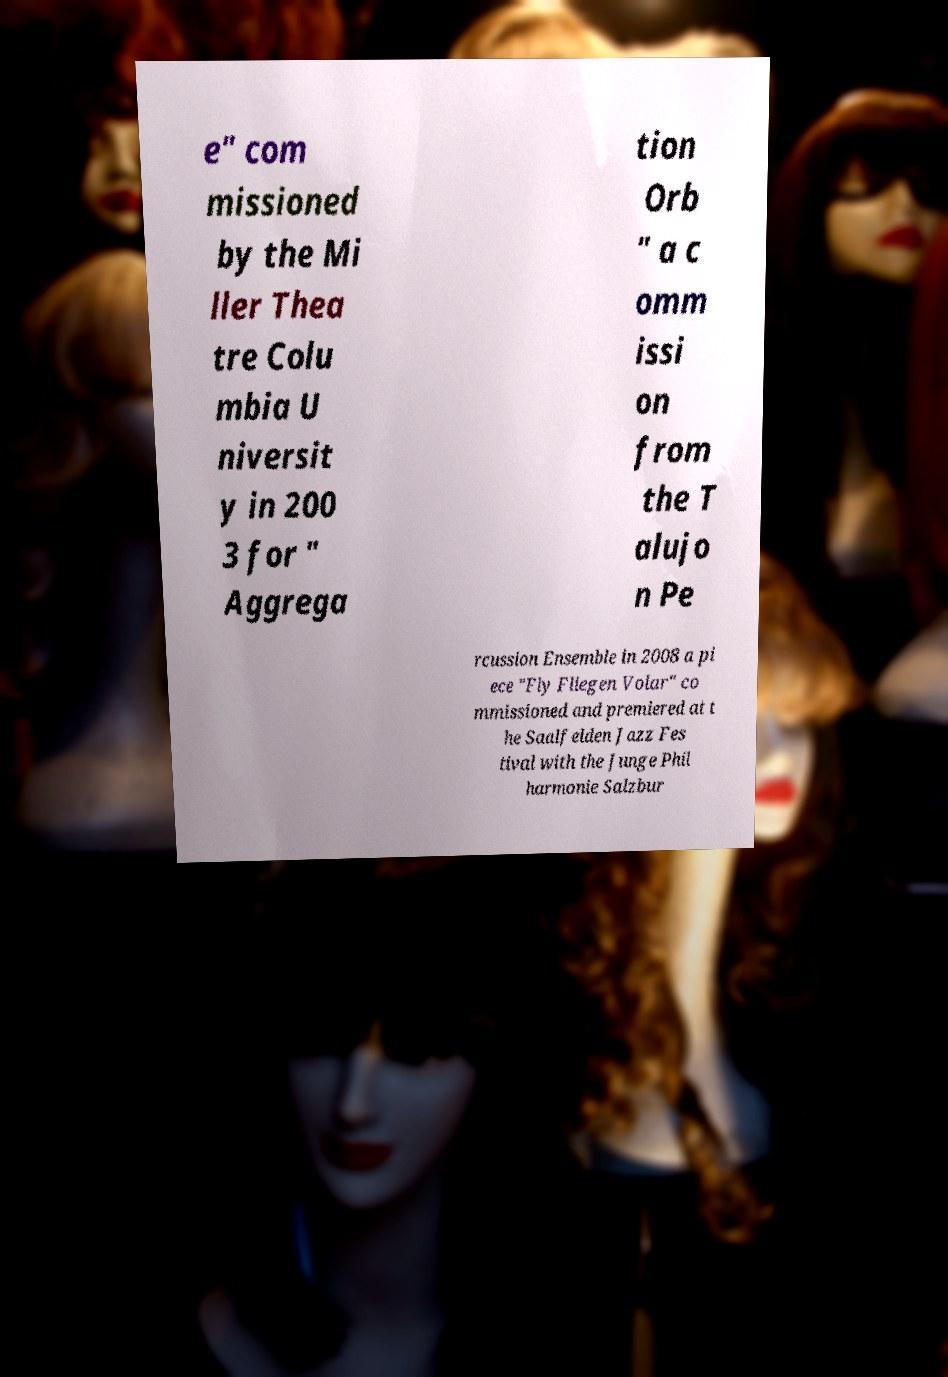Please identify and transcribe the text found in this image. e" com missioned by the Mi ller Thea tre Colu mbia U niversit y in 200 3 for " Aggrega tion Orb " a c omm issi on from the T alujo n Pe rcussion Ensemble in 2008 a pi ece "Fly Fliegen Volar" co mmissioned and premiered at t he Saalfelden Jazz Fes tival with the Junge Phil harmonie Salzbur 